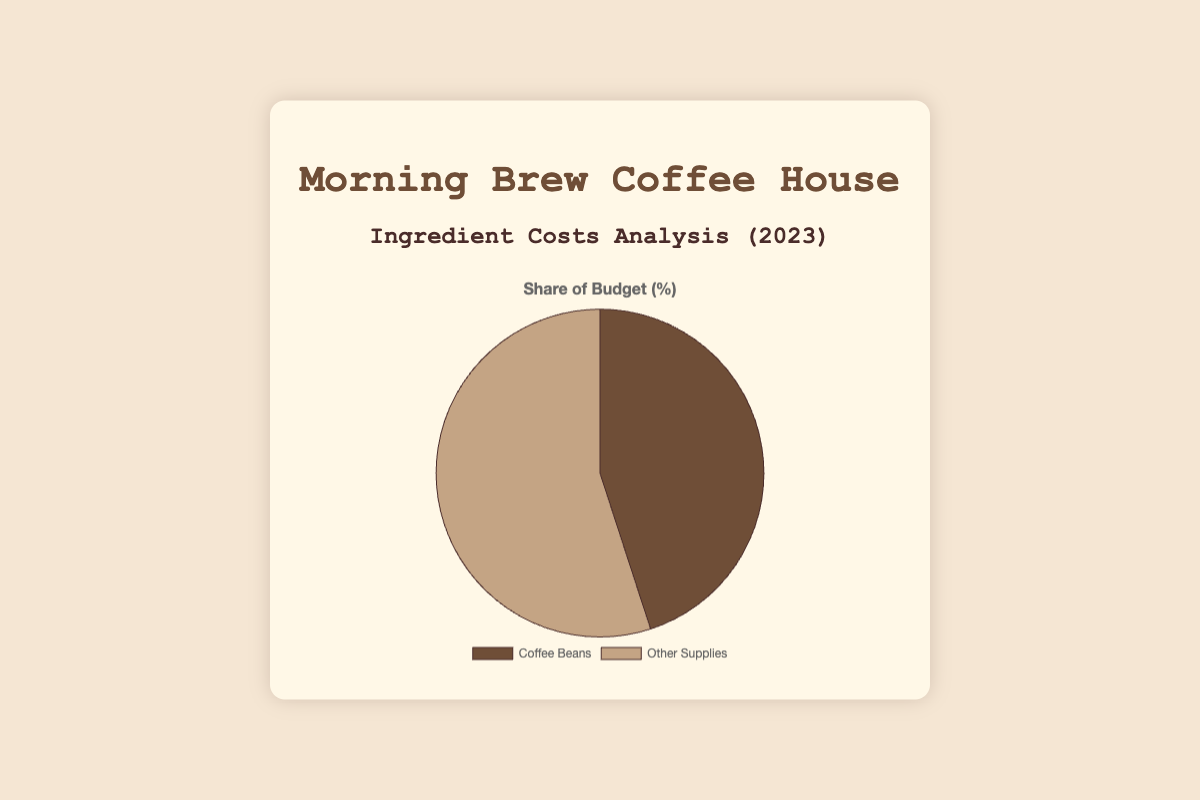What percentage of the budget is spent on coffee beans? The figure shows that the "Coffee Beans" occupy a portion of the pie chart, labeled with its corresponding percentage.
Answer: 45% What percentage of the budget is spent on other supplies? The figure labels the "Other Supplies" portion of the pie chart, specifying its percentage.
Answer: 55% Is the budget for coffee beans less than or greater than the budget for other supplies? By comparing the two percentages given in the pie chart (45% for Coffee Beans and 55% for Other Supplies), it is clear that 45% (coffee beans) is less than 55% (other supplies).
Answer: Less than What is the total percentage for coffee beans and other supplies combined? The pie chart is divided into a portion for coffee beans and another for other supplies, totaling the percentage of both gives 45% + 55%.
Answer: 100% If the total budget is $50,000, how much money is spent on coffee beans? Calculate 45% of $50,000. This can be done by multiplying $50,000 by 0.45. $50,000 * 0.45 gives the amount spent on coffee beans.
Answer: $22,500 If the total budget is $50,000, how much money is spent on other supplies? Given that 55% of the total budget is for other supplies, calculate 55% of $50,000. This can be done by multiplying $50,000 by 0.55. $50,000 * 0.55 gives the amount spent on other supplies.
Answer: $27,500 Which segment of the pie chart is visually larger? The visual comparison of the sizes of the chart segments shows that the "Other Supplies" part is larger than the "Coffee Beans" part.
Answer: Other Supplies By what percentage is the budget for other supplies higher than the budget for coffee beans? Subtract the percentage for coffee beans from the percentage for other supplies (55% - 45%), which gives the difference in percentage.
Answer: 10% What is the average percentage of the budget spent on each category shown in the pie chart? Since there are only two categories: coffee beans and other supplies, add the two percentages and divide by 2: (45% + 55%) / 2.
Answer: 50% What is the combined budget percentage for milk, sugar, cups, filters, flavorings, and cleaning supplies? All these items are part of "Other Supplies" which together occupy 55% of the budget, as indicated by the pie chart.
Answer: 55% 